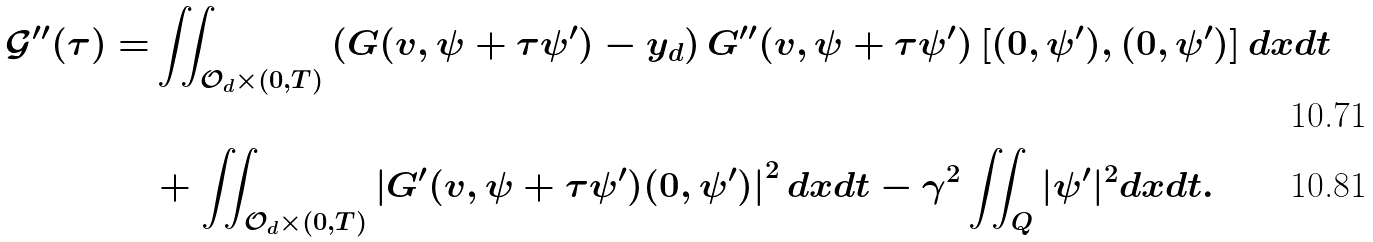Convert formula to latex. <formula><loc_0><loc_0><loc_500><loc_500>\mathcal { G } ^ { \prime \prime } ( \tau ) = & \iint _ { \mathcal { O } _ { d } \times ( 0 , T ) } \left ( G ( v , \psi + \tau \psi ^ { \prime } ) - y _ { d } \right ) G ^ { \prime \prime } ( v , \psi + \tau \psi ^ { \prime } ) \left [ ( 0 , \psi ^ { \prime } ) , ( 0 , \psi ^ { \prime } ) \right ] d x d t \\ & + \iint _ { \mathcal { O } _ { d } \times ( 0 , T ) } \left | G ^ { \prime } ( v , \psi + \tau \psi ^ { \prime } ) ( 0 , \psi ^ { \prime } ) \right | ^ { 2 } d x d t - \gamma ^ { 2 } \iint _ { Q } | \psi ^ { \prime } | ^ { 2 } d x d t .</formula> 